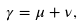Convert formula to latex. <formula><loc_0><loc_0><loc_500><loc_500>\gamma = \mu + \nu ,</formula> 